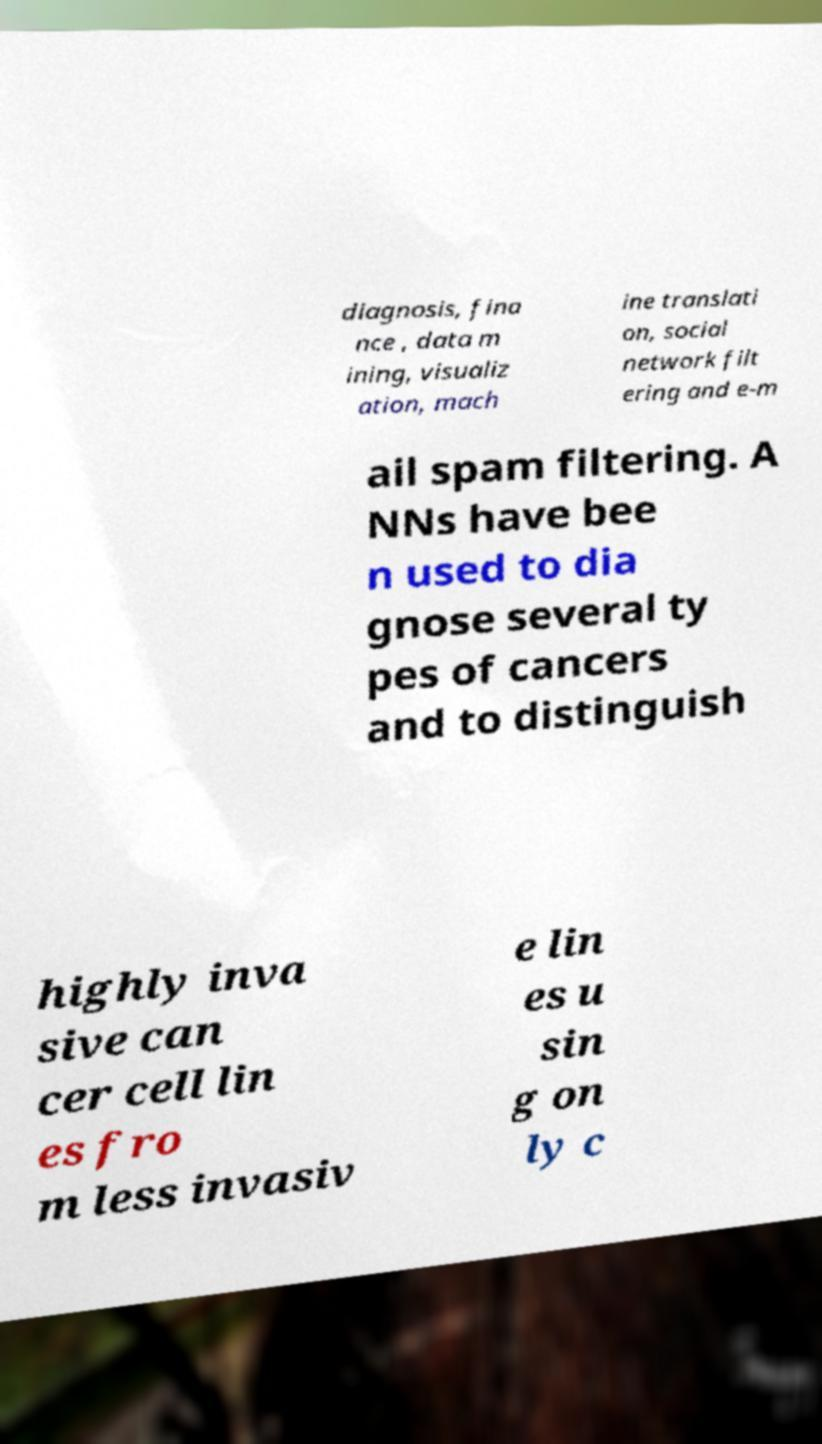Can you accurately transcribe the text from the provided image for me? diagnosis, fina nce , data m ining, visualiz ation, mach ine translati on, social network filt ering and e-m ail spam filtering. A NNs have bee n used to dia gnose several ty pes of cancers and to distinguish highly inva sive can cer cell lin es fro m less invasiv e lin es u sin g on ly c 